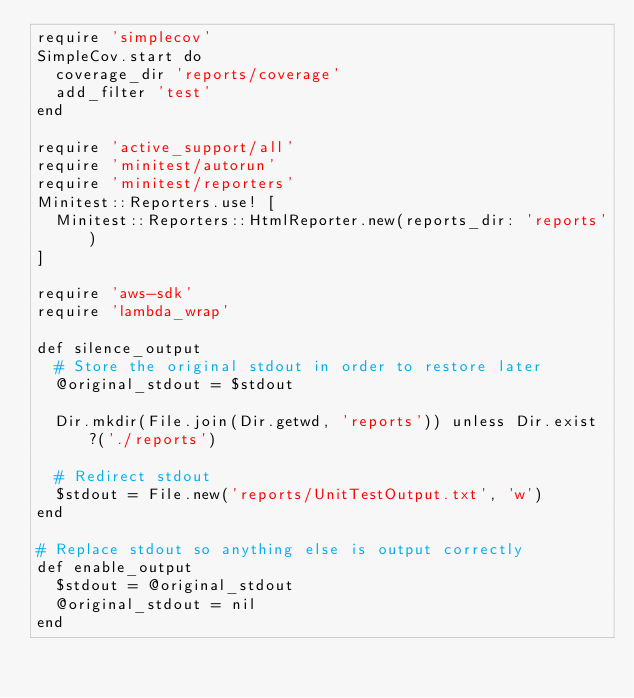Convert code to text. <code><loc_0><loc_0><loc_500><loc_500><_Ruby_>require 'simplecov'
SimpleCov.start do
  coverage_dir 'reports/coverage'
  add_filter 'test'
end

require 'active_support/all'
require 'minitest/autorun'
require 'minitest/reporters'
Minitest::Reporters.use! [
  Minitest::Reporters::HtmlReporter.new(reports_dir: 'reports')
]

require 'aws-sdk'
require 'lambda_wrap'

def silence_output
  # Store the original stdout in order to restore later
  @original_stdout = $stdout

  Dir.mkdir(File.join(Dir.getwd, 'reports')) unless Dir.exist?('./reports')

  # Redirect stdout
  $stdout = File.new('reports/UnitTestOutput.txt', 'w')
end

# Replace stdout so anything else is output correctly
def enable_output
  $stdout = @original_stdout
  @original_stdout = nil
end
</code> 